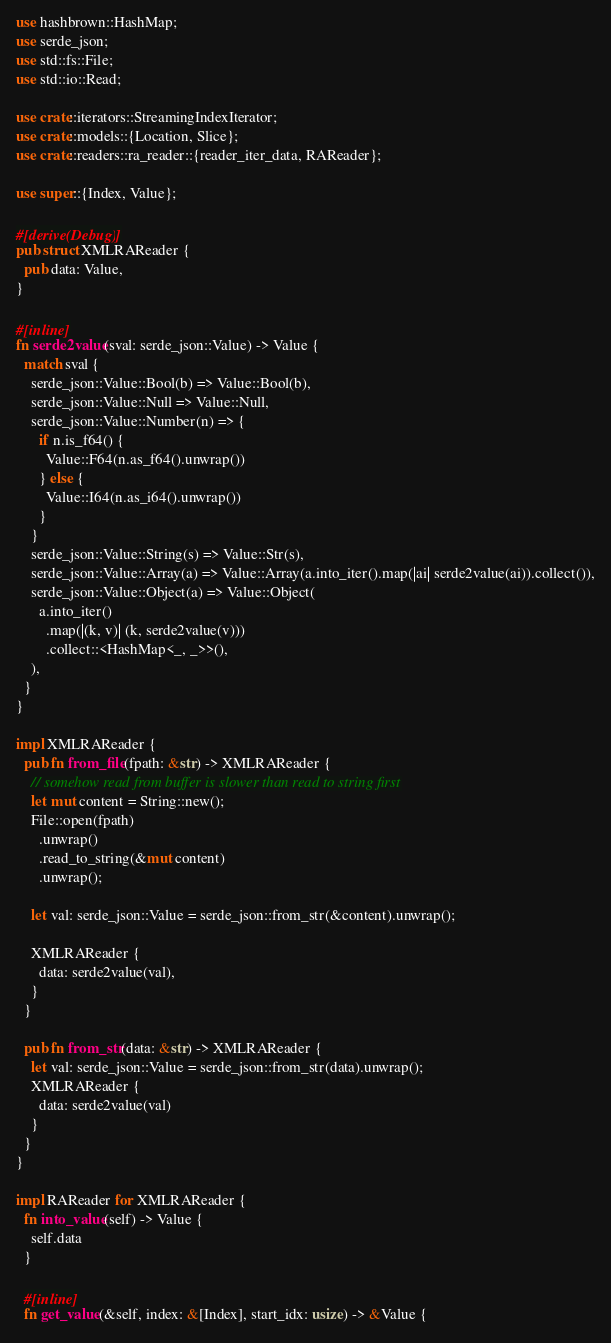<code> <loc_0><loc_0><loc_500><loc_500><_Rust_>use hashbrown::HashMap;
use serde_json;
use std::fs::File;
use std::io::Read;

use crate::iterators::StreamingIndexIterator;
use crate::models::{Location, Slice};
use crate::readers::ra_reader::{reader_iter_data, RAReader};

use super::{Index, Value};

#[derive(Debug)]
pub struct XMLRAReader {
  pub data: Value,
}

#[inline]
fn serde2value(sval: serde_json::Value) -> Value {
  match sval {
    serde_json::Value::Bool(b) => Value::Bool(b),
    serde_json::Value::Null => Value::Null,
    serde_json::Value::Number(n) => {
      if n.is_f64() {
        Value::F64(n.as_f64().unwrap())
      } else {
        Value::I64(n.as_i64().unwrap())
      }
    }
    serde_json::Value::String(s) => Value::Str(s),
    serde_json::Value::Array(a) => Value::Array(a.into_iter().map(|ai| serde2value(ai)).collect()),
    serde_json::Value::Object(a) => Value::Object(
      a.into_iter()
        .map(|(k, v)| (k, serde2value(v)))
        .collect::<HashMap<_, _>>(),
    ),
  }
}

impl XMLRAReader {
  pub fn from_file(fpath: &str) -> XMLRAReader {
    // somehow read from buffer is slower than read to string first
    let mut content = String::new();
    File::open(fpath)
      .unwrap()
      .read_to_string(&mut content)
      .unwrap();

    let val: serde_json::Value = serde_json::from_str(&content).unwrap();

    XMLRAReader {
      data: serde2value(val),
    }
  }

  pub fn from_str(data: &str) -> XMLRAReader {
    let val: serde_json::Value = serde_json::from_str(data).unwrap();
    XMLRAReader {
      data: serde2value(val)
    }
  }
}

impl RAReader for XMLRAReader {
  fn into_value(self) -> Value {
    self.data
  }

  #[inline]
  fn get_value(&self, index: &[Index], start_idx: usize) -> &Value {</code> 